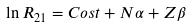Convert formula to latex. <formula><loc_0><loc_0><loc_500><loc_500>\ln R _ { 2 1 } = C o s t + N \alpha + Z \beta</formula> 